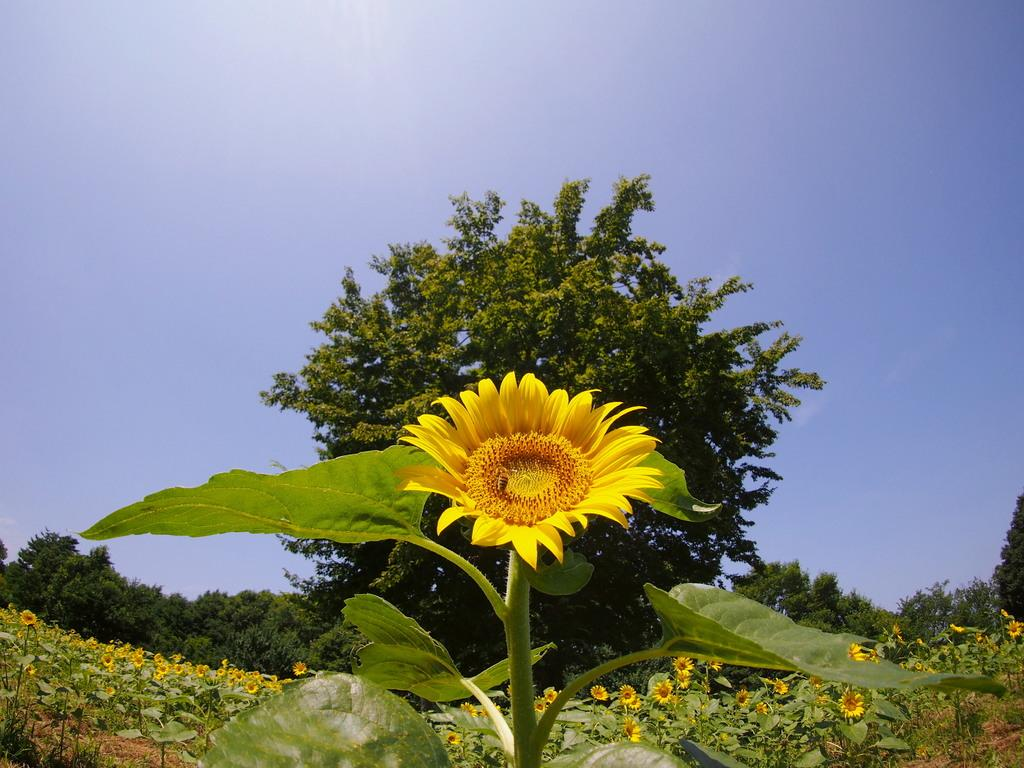What type of farm is shown in the image? There is a sunflower farm in the image. What can be seen in the background of the image? There are trees and the sky visible in the background of the image. Can you see the donkey's fang in the aftermath of the storm in the image? There is no donkey, fang, or storm present in the image; it features a sunflower farm with trees and the sky in the background. 